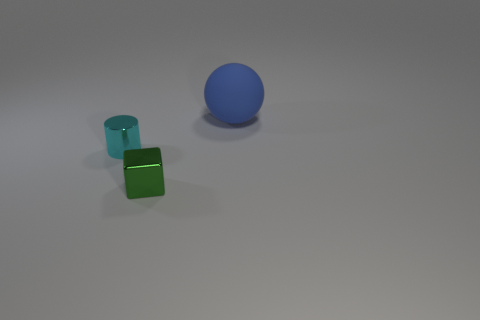What is the shape of the small green thing that is made of the same material as the cylinder?
Offer a terse response. Cube. There is a metal thing right of the cyan metallic thing; does it have the same size as the metallic thing that is behind the tiny green metal cube?
Keep it short and to the point. Yes. Are there more large things right of the tiny cyan cylinder than big rubber balls to the left of the large blue ball?
Ensure brevity in your answer.  Yes. What number of metal blocks are in front of the shiny thing on the left side of the green cube?
Keep it short and to the point. 1. Is there anything else that is the same material as the sphere?
Give a very brief answer. No. There is a object that is to the left of the object that is in front of the object left of the block; what is its material?
Your response must be concise. Metal. There is a object that is behind the small green shiny thing and right of the tiny cyan object; what is its material?
Ensure brevity in your answer.  Rubber. There is a thing behind the cylinder that is behind the block; how big is it?
Keep it short and to the point. Large. Do the thing that is in front of the cyan metal cylinder and the object behind the tiny cyan thing have the same color?
Your response must be concise. No. How many green metal cubes are in front of the thing that is to the left of the shiny thing in front of the cyan cylinder?
Ensure brevity in your answer.  1. 